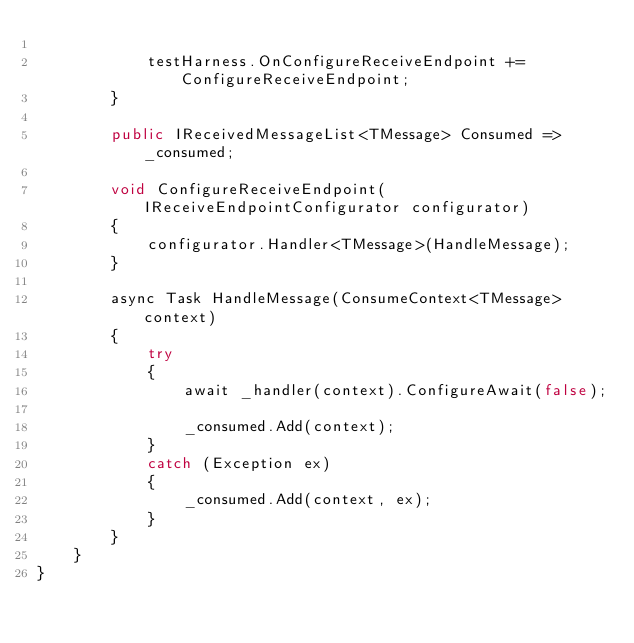Convert code to text. <code><loc_0><loc_0><loc_500><loc_500><_C#_>
            testHarness.OnConfigureReceiveEndpoint += ConfigureReceiveEndpoint;
        }

        public IReceivedMessageList<TMessage> Consumed => _consumed;

        void ConfigureReceiveEndpoint(IReceiveEndpointConfigurator configurator)
        {
            configurator.Handler<TMessage>(HandleMessage);
        }

        async Task HandleMessage(ConsumeContext<TMessage> context)
        {
            try
            {
                await _handler(context).ConfigureAwait(false);

                _consumed.Add(context);
            }
            catch (Exception ex)
            {
                _consumed.Add(context, ex);
            }
        }
    }
}
</code> 